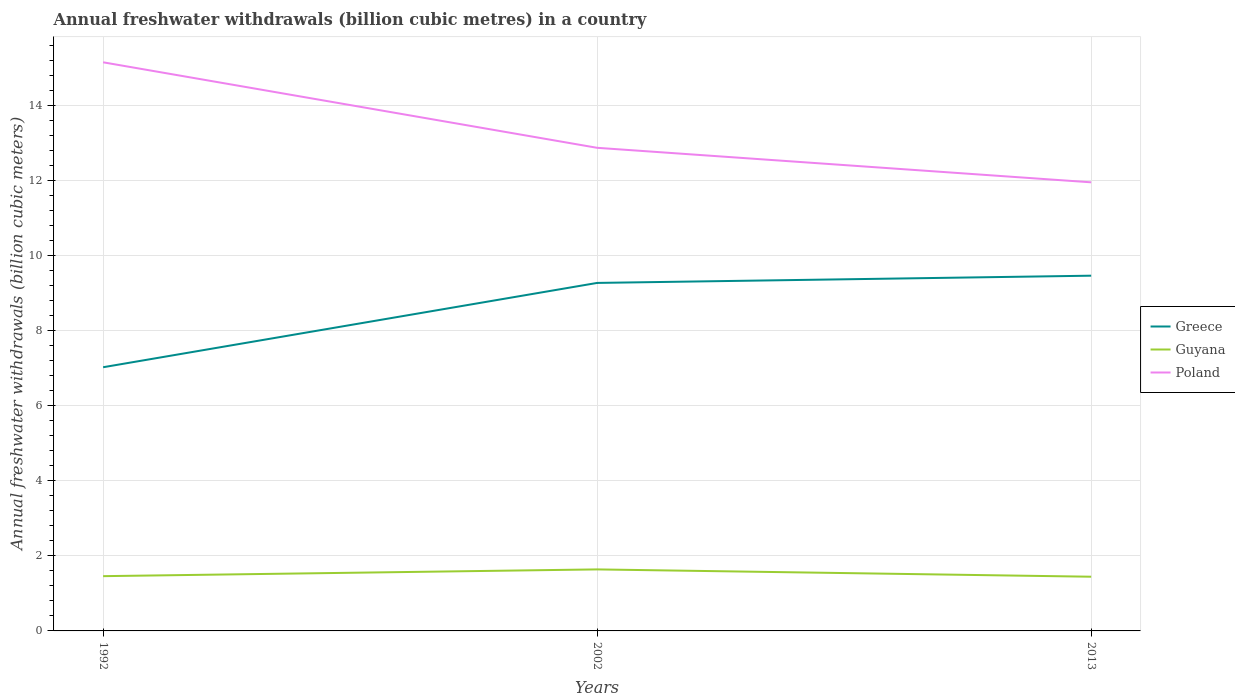Across all years, what is the maximum annual freshwater withdrawals in Greece?
Provide a short and direct response. 7.03. What is the total annual freshwater withdrawals in Guyana in the graph?
Make the answer very short. 0.01. What is the difference between the highest and the second highest annual freshwater withdrawals in Greece?
Make the answer very short. 2.44. Is the annual freshwater withdrawals in Greece strictly greater than the annual freshwater withdrawals in Poland over the years?
Your response must be concise. Yes. How many lines are there?
Give a very brief answer. 3. Does the graph contain any zero values?
Ensure brevity in your answer.  No. Where does the legend appear in the graph?
Ensure brevity in your answer.  Center right. What is the title of the graph?
Your response must be concise. Annual freshwater withdrawals (billion cubic metres) in a country. What is the label or title of the Y-axis?
Ensure brevity in your answer.  Annual freshwater withdrawals (billion cubic meters). What is the Annual freshwater withdrawals (billion cubic meters) of Greece in 1992?
Your response must be concise. 7.03. What is the Annual freshwater withdrawals (billion cubic meters) of Guyana in 1992?
Provide a succinct answer. 1.46. What is the Annual freshwater withdrawals (billion cubic meters) in Poland in 1992?
Your response must be concise. 15.16. What is the Annual freshwater withdrawals (billion cubic meters) in Greece in 2002?
Give a very brief answer. 9.28. What is the Annual freshwater withdrawals (billion cubic meters) of Guyana in 2002?
Keep it short and to the point. 1.64. What is the Annual freshwater withdrawals (billion cubic meters) of Poland in 2002?
Make the answer very short. 12.88. What is the Annual freshwater withdrawals (billion cubic meters) of Greece in 2013?
Provide a short and direct response. 9.47. What is the Annual freshwater withdrawals (billion cubic meters) in Guyana in 2013?
Your answer should be very brief. 1.45. What is the Annual freshwater withdrawals (billion cubic meters) of Poland in 2013?
Ensure brevity in your answer.  11.96. Across all years, what is the maximum Annual freshwater withdrawals (billion cubic meters) of Greece?
Your response must be concise. 9.47. Across all years, what is the maximum Annual freshwater withdrawals (billion cubic meters) of Guyana?
Your answer should be very brief. 1.64. Across all years, what is the maximum Annual freshwater withdrawals (billion cubic meters) in Poland?
Your answer should be compact. 15.16. Across all years, what is the minimum Annual freshwater withdrawals (billion cubic meters) in Greece?
Give a very brief answer. 7.03. Across all years, what is the minimum Annual freshwater withdrawals (billion cubic meters) in Guyana?
Provide a succinct answer. 1.45. Across all years, what is the minimum Annual freshwater withdrawals (billion cubic meters) of Poland?
Provide a short and direct response. 11.96. What is the total Annual freshwater withdrawals (billion cubic meters) in Greece in the graph?
Your answer should be very brief. 25.78. What is the total Annual freshwater withdrawals (billion cubic meters) of Guyana in the graph?
Ensure brevity in your answer.  4.54. What is the total Annual freshwater withdrawals (billion cubic meters) of Poland in the graph?
Provide a short and direct response. 40. What is the difference between the Annual freshwater withdrawals (billion cubic meters) in Greece in 1992 and that in 2002?
Make the answer very short. -2.25. What is the difference between the Annual freshwater withdrawals (billion cubic meters) in Guyana in 1992 and that in 2002?
Keep it short and to the point. -0.18. What is the difference between the Annual freshwater withdrawals (billion cubic meters) in Poland in 1992 and that in 2002?
Provide a short and direct response. 2.28. What is the difference between the Annual freshwater withdrawals (billion cubic meters) in Greece in 1992 and that in 2013?
Keep it short and to the point. -2.44. What is the difference between the Annual freshwater withdrawals (billion cubic meters) in Guyana in 1992 and that in 2013?
Offer a terse response. 0.01. What is the difference between the Annual freshwater withdrawals (billion cubic meters) of Greece in 2002 and that in 2013?
Keep it short and to the point. -0.19. What is the difference between the Annual freshwater withdrawals (billion cubic meters) in Guyana in 2002 and that in 2013?
Make the answer very short. 0.2. What is the difference between the Annual freshwater withdrawals (billion cubic meters) in Poland in 2002 and that in 2013?
Your answer should be compact. 0.92. What is the difference between the Annual freshwater withdrawals (billion cubic meters) in Greece in 1992 and the Annual freshwater withdrawals (billion cubic meters) in Guyana in 2002?
Your answer should be very brief. 5.39. What is the difference between the Annual freshwater withdrawals (billion cubic meters) of Greece in 1992 and the Annual freshwater withdrawals (billion cubic meters) of Poland in 2002?
Your response must be concise. -5.85. What is the difference between the Annual freshwater withdrawals (billion cubic meters) of Guyana in 1992 and the Annual freshwater withdrawals (billion cubic meters) of Poland in 2002?
Offer a terse response. -11.42. What is the difference between the Annual freshwater withdrawals (billion cubic meters) of Greece in 1992 and the Annual freshwater withdrawals (billion cubic meters) of Guyana in 2013?
Keep it short and to the point. 5.58. What is the difference between the Annual freshwater withdrawals (billion cubic meters) in Greece in 1992 and the Annual freshwater withdrawals (billion cubic meters) in Poland in 2013?
Offer a very short reply. -4.93. What is the difference between the Annual freshwater withdrawals (billion cubic meters) of Greece in 2002 and the Annual freshwater withdrawals (billion cubic meters) of Guyana in 2013?
Your answer should be very brief. 7.83. What is the difference between the Annual freshwater withdrawals (billion cubic meters) in Greece in 2002 and the Annual freshwater withdrawals (billion cubic meters) in Poland in 2013?
Provide a succinct answer. -2.68. What is the difference between the Annual freshwater withdrawals (billion cubic meters) of Guyana in 2002 and the Annual freshwater withdrawals (billion cubic meters) of Poland in 2013?
Make the answer very short. -10.32. What is the average Annual freshwater withdrawals (billion cubic meters) of Greece per year?
Give a very brief answer. 8.59. What is the average Annual freshwater withdrawals (billion cubic meters) in Guyana per year?
Your response must be concise. 1.51. What is the average Annual freshwater withdrawals (billion cubic meters) of Poland per year?
Give a very brief answer. 13.33. In the year 1992, what is the difference between the Annual freshwater withdrawals (billion cubic meters) of Greece and Annual freshwater withdrawals (billion cubic meters) of Guyana?
Keep it short and to the point. 5.57. In the year 1992, what is the difference between the Annual freshwater withdrawals (billion cubic meters) in Greece and Annual freshwater withdrawals (billion cubic meters) in Poland?
Keep it short and to the point. -8.13. In the year 1992, what is the difference between the Annual freshwater withdrawals (billion cubic meters) in Guyana and Annual freshwater withdrawals (billion cubic meters) in Poland?
Provide a succinct answer. -13.7. In the year 2002, what is the difference between the Annual freshwater withdrawals (billion cubic meters) of Greece and Annual freshwater withdrawals (billion cubic meters) of Guyana?
Your answer should be compact. 7.64. In the year 2002, what is the difference between the Annual freshwater withdrawals (billion cubic meters) of Greece and Annual freshwater withdrawals (billion cubic meters) of Poland?
Your answer should be very brief. -3.6. In the year 2002, what is the difference between the Annual freshwater withdrawals (billion cubic meters) of Guyana and Annual freshwater withdrawals (billion cubic meters) of Poland?
Keep it short and to the point. -11.24. In the year 2013, what is the difference between the Annual freshwater withdrawals (billion cubic meters) in Greece and Annual freshwater withdrawals (billion cubic meters) in Guyana?
Ensure brevity in your answer.  8.03. In the year 2013, what is the difference between the Annual freshwater withdrawals (billion cubic meters) in Greece and Annual freshwater withdrawals (billion cubic meters) in Poland?
Provide a succinct answer. -2.49. In the year 2013, what is the difference between the Annual freshwater withdrawals (billion cubic meters) in Guyana and Annual freshwater withdrawals (billion cubic meters) in Poland?
Provide a succinct answer. -10.52. What is the ratio of the Annual freshwater withdrawals (billion cubic meters) of Greece in 1992 to that in 2002?
Offer a terse response. 0.76. What is the ratio of the Annual freshwater withdrawals (billion cubic meters) in Guyana in 1992 to that in 2002?
Keep it short and to the point. 0.89. What is the ratio of the Annual freshwater withdrawals (billion cubic meters) in Poland in 1992 to that in 2002?
Ensure brevity in your answer.  1.18. What is the ratio of the Annual freshwater withdrawals (billion cubic meters) of Greece in 1992 to that in 2013?
Provide a short and direct response. 0.74. What is the ratio of the Annual freshwater withdrawals (billion cubic meters) of Guyana in 1992 to that in 2013?
Your answer should be very brief. 1.01. What is the ratio of the Annual freshwater withdrawals (billion cubic meters) in Poland in 1992 to that in 2013?
Make the answer very short. 1.27. What is the ratio of the Annual freshwater withdrawals (billion cubic meters) in Greece in 2002 to that in 2013?
Provide a succinct answer. 0.98. What is the ratio of the Annual freshwater withdrawals (billion cubic meters) of Guyana in 2002 to that in 2013?
Keep it short and to the point. 1.13. What is the ratio of the Annual freshwater withdrawals (billion cubic meters) in Poland in 2002 to that in 2013?
Provide a short and direct response. 1.08. What is the difference between the highest and the second highest Annual freshwater withdrawals (billion cubic meters) of Greece?
Make the answer very short. 0.19. What is the difference between the highest and the second highest Annual freshwater withdrawals (billion cubic meters) in Guyana?
Offer a very short reply. 0.18. What is the difference between the highest and the second highest Annual freshwater withdrawals (billion cubic meters) in Poland?
Keep it short and to the point. 2.28. What is the difference between the highest and the lowest Annual freshwater withdrawals (billion cubic meters) of Greece?
Keep it short and to the point. 2.44. What is the difference between the highest and the lowest Annual freshwater withdrawals (billion cubic meters) in Guyana?
Make the answer very short. 0.2. What is the difference between the highest and the lowest Annual freshwater withdrawals (billion cubic meters) of Poland?
Keep it short and to the point. 3.2. 